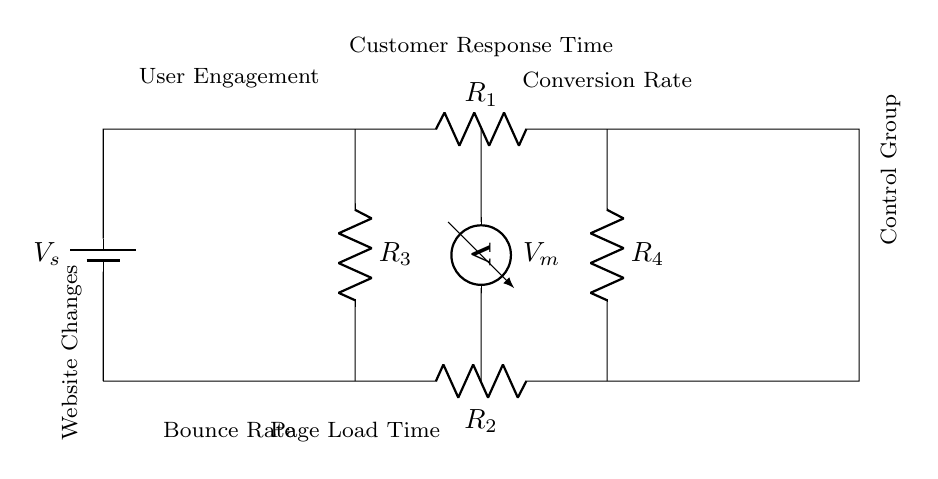what is the voltage source in this circuit? The circuit has a voltage source labeled as V_s, which supplies the necessary potential difference for the circuit's operation.
Answer: V_s what are the resistors present in this circuit? The circuit includes four resistors, labeled R_1, R_2, R_3, and R_4. These resistors are connected in a way to measure various parameters related to customer response time.
Answer: R_1, R_2, R_3, R_4 what parameter does the voltmeter measure in this circuit? The voltmeter is positioned to measure the voltage drop across certain components, specifically reflecting the customer response time based on engagement metrics.
Answer: Customer Response Time how do the resistors R_3 and R_4 compare in the circuit? Resistors R_3 and R_4 are connected in parallel, which indicates they share the same voltage across their terminals, affecting the overall current in the circuit.
Answer: Parallel what does a higher value of the conversion rate suggest about the circuit's performance? A higher conversion rate usually implies that users are responding positively to the website changes, indicating that those changes are effective in engaging customers and improving their experience.
Answer: Effectiveness if the bounce rate decreases, what circuit value might that influence? A decrease in bounce rate would likely lead to an increase in the conversion rate, as fewer users leave the site immediately, suggesting a better engagement with the website.
Answer: Conversion Rate what is the relationship between page load time and user engagement in this circuit? Page load time is inversely related to user engagement; slower load times can lead to decreased user engagement while faster load times typically enhance it, reflected in the circuit metrics.
Answer: Inverse 